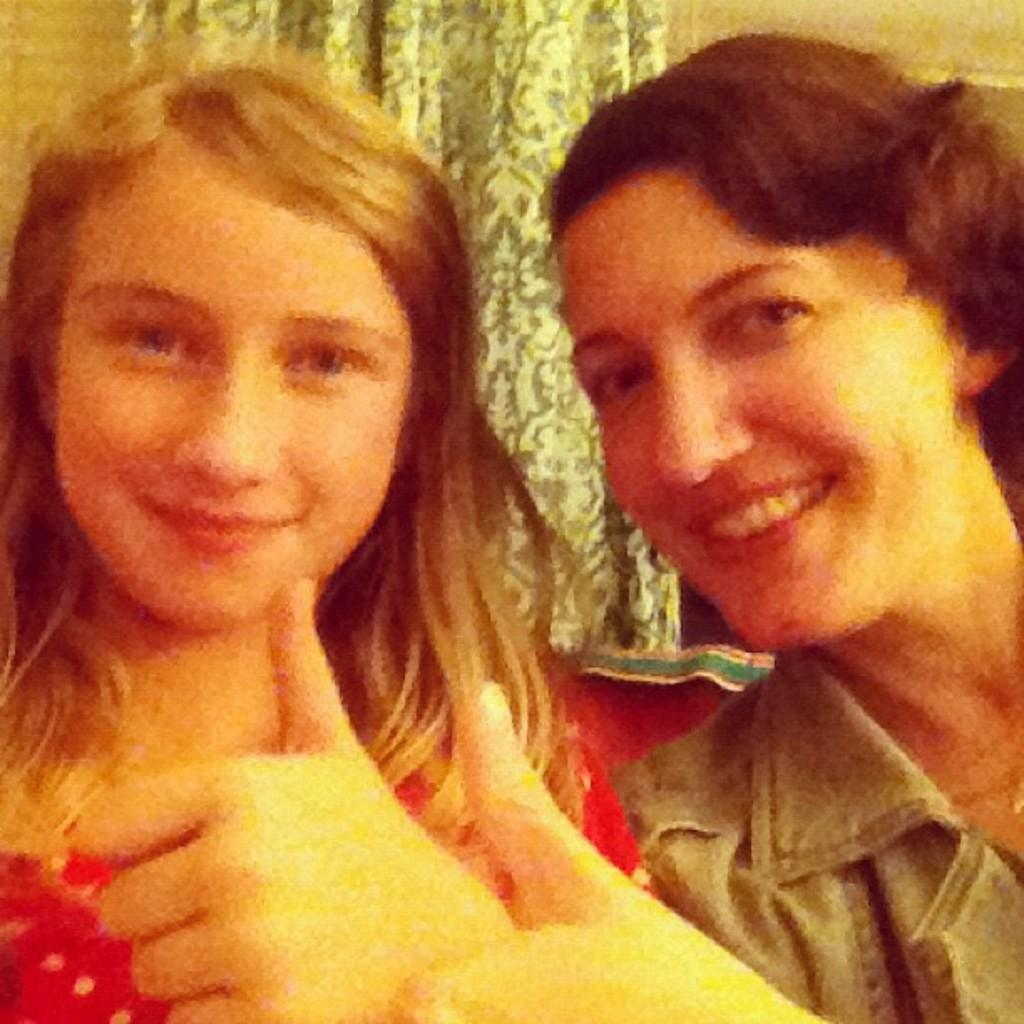How many women are in the image? There are two women in the image. What is the woman in the red dress wearing? The woman in the red dress is wearing a red dress. What gesture are both women making in the image? Both women are raising their thumbs up in the image. What can be seen in the background of the image? There is a curtain visible in the background. What expression do the women have in the image? The women are smiling in the image. What type of advertisement can be seen on the list in the image? There is no advertisement or list present in the image. 